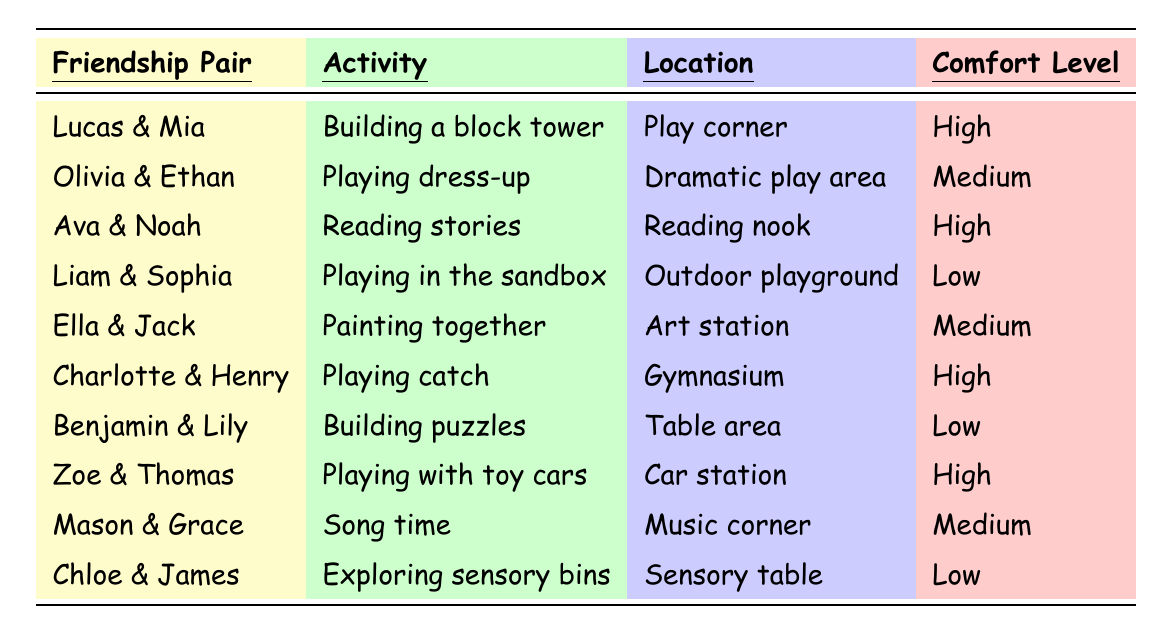What activity do Lucas and Mia enjoy together? The table lists the friendship pairing "Lucas & Mia" alongside their activity, which is "Building a block tower."
Answer: Building a block tower Which friendship pairing has a low comfort level? Scanning through the table, I see "Liam & Sophia," "Benjamin & Lily," and "Chloe & James," which all have a comfort level marked as low.
Answer: Liam & Sophia, Benjamin & Lily, Chloe & James How many friendship pairings are involved in high comfort level activities? The table shows three pairs: Lucas & Mia, Ava & Noah, Charlotte & Henry, and Zoe & Thomas, which all have a high comfort level. Therefore, there are four pairings.
Answer: Four pairings Which location do Olivia and Ethan play in? Referring to the table, Olivia & Ethan are associated with the "Dramatic play area."
Answer: Dramatic play area Are there more pairs in the high comfort level group or low comfort level group? The table indicates there are four pairs with high comfort levels (Lucas & Mia, Ava & Noah, Charlotte & Henry, and Zoe & Thomas) and three pairs with low comfort levels (Liam & Sophia, Benjamin & Lily, and Chloe & James). Thus, there are more high comfort level pairs.
Answer: High comfort level pairs are more What is the common activity for friendship pairs with a medium comfort level? The table lists the medium comfort level activities as "Playing dress-up," "Painting together," and "Song time." So the common activities are these three.
Answer: Playing dress-up, Painting together, Song time How many activities take place in the outdoor playground? Checking the table, there is only one identified pairing that plays in the outdoor playground, which is Liam & Sophia.
Answer: One activity Which friendship pair is associated with reading stories? The table records the friendship pairing "Ava & Noah" as engaging in the activity of "Reading stories."
Answer: Ava & Noah Which two pairs play in the art station? The table indicates that Ella & Jack are the only pair listed in the art station. Therefore, only one pair is associated with that location.
Answer: One pair (Ella & Jack) What activity do Zoe and Thomas do together, and what is their comfort level? The table indicates that Zoe & Thomas play with toy cars, and their comfort level is high.
Answer: Playing with toy cars; High comfort level Is Mason paired with a friend who shares their activity interest? Mason is paired with Grace for "Song time," and we would need to check if any other pair also has a medium comfort level and engages in song-related activities, but no other pair is indicated for that. So, no, they do not share their interest.
Answer: No 